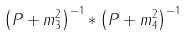Convert formula to latex. <formula><loc_0><loc_0><loc_500><loc_500>\left ( P + m _ { 3 } ^ { 2 } \right ) ^ { - 1 } \ast \left ( P + m _ { 4 } ^ { 2 } \right ) ^ { - 1 }</formula> 